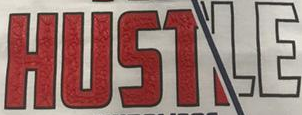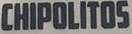Read the text from these images in sequence, separated by a semicolon. HUSTLE; CHIPOLITOS 